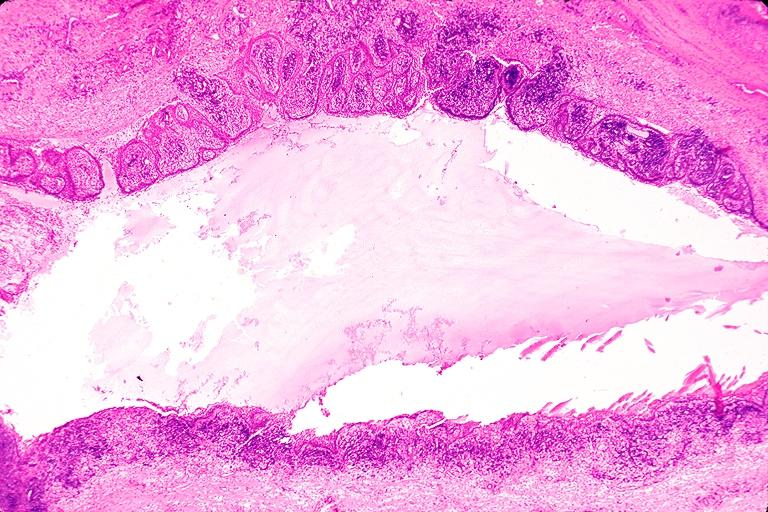what does this image show?
Answer the question using a single word or phrase. Radicular cyst 